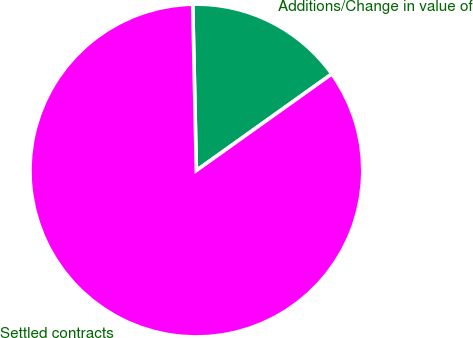Convert chart. <chart><loc_0><loc_0><loc_500><loc_500><pie_chart><fcel>Additions/Change in value of<fcel>Settled contracts<nl><fcel>15.49%<fcel>84.51%<nl></chart> 